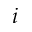<formula> <loc_0><loc_0><loc_500><loc_500>i</formula> 